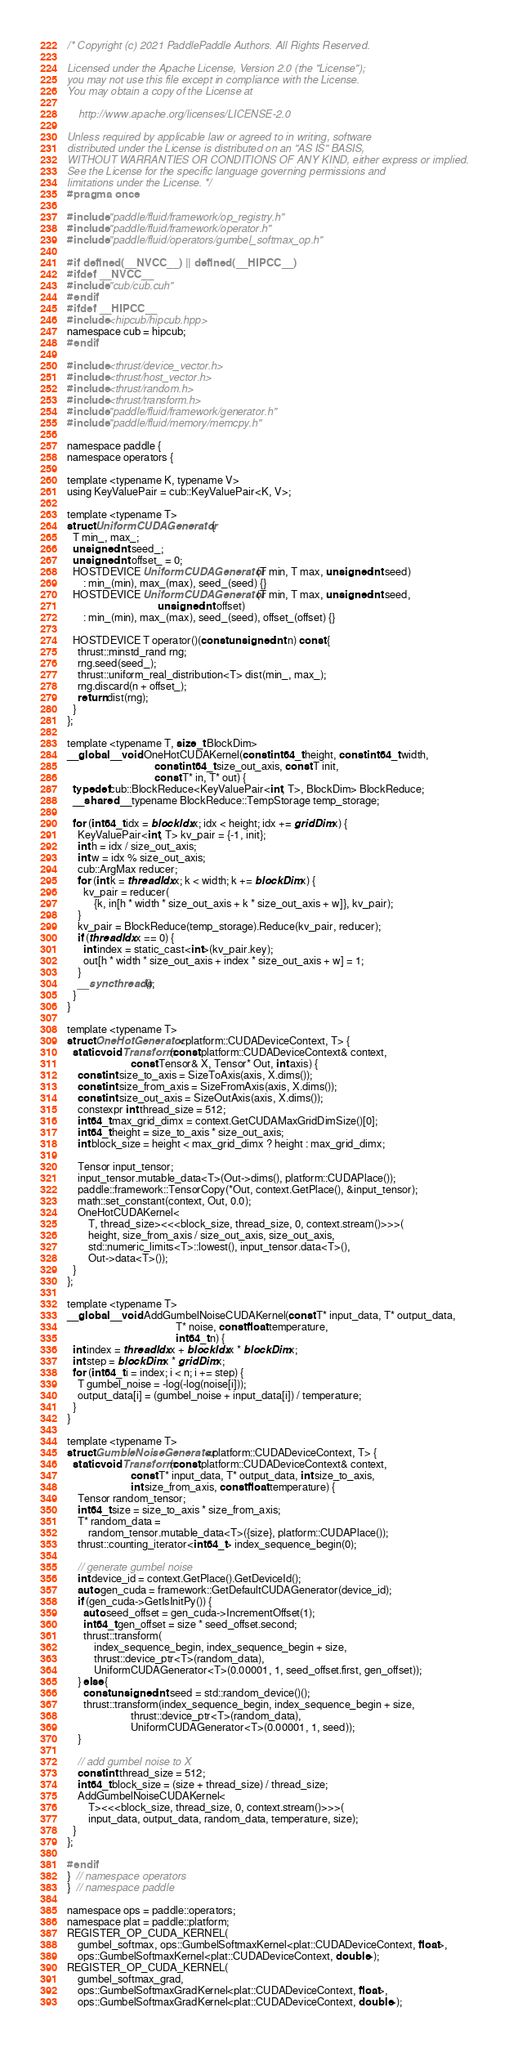Convert code to text. <code><loc_0><loc_0><loc_500><loc_500><_Cuda_>/* Copyright (c) 2021 PaddlePaddle Authors. All Rights Reserved.

Licensed under the Apache License, Version 2.0 (the "License");
you may not use this file except in compliance with the License.
You may obtain a copy of the License at

    http://www.apache.org/licenses/LICENSE-2.0

Unless required by applicable law or agreed to in writing, software
distributed under the License is distributed on an "AS IS" BASIS,
WITHOUT WARRANTIES OR CONDITIONS OF ANY KIND, either express or implied.
See the License for the specific language governing permissions and
limitations under the License. */
#pragma once

#include "paddle/fluid/framework/op_registry.h"
#include "paddle/fluid/framework/operator.h"
#include "paddle/fluid/operators/gumbel_softmax_op.h"

#if defined(__NVCC__) || defined(__HIPCC__)
#ifdef __NVCC__
#include "cub/cub.cuh"
#endif
#ifdef __HIPCC__
#include <hipcub/hipcub.hpp>
namespace cub = hipcub;
#endif

#include <thrust/device_vector.h>
#include <thrust/host_vector.h>
#include <thrust/random.h>
#include <thrust/transform.h>
#include "paddle/fluid/framework/generator.h"
#include "paddle/fluid/memory/memcpy.h"

namespace paddle {
namespace operators {

template <typename K, typename V>
using KeyValuePair = cub::KeyValuePair<K, V>;

template <typename T>
struct UniformCUDAGenerator {
  T min_, max_;
  unsigned int seed_;
  unsigned int offset_ = 0;
  HOSTDEVICE UniformCUDAGenerator(T min, T max, unsigned int seed)
      : min_(min), max_(max), seed_(seed) {}
  HOSTDEVICE UniformCUDAGenerator(T min, T max, unsigned int seed,
                                  unsigned int offset)
      : min_(min), max_(max), seed_(seed), offset_(offset) {}

  HOSTDEVICE T operator()(const unsigned int n) const {
    thrust::minstd_rand rng;
    rng.seed(seed_);
    thrust::uniform_real_distribution<T> dist(min_, max_);
    rng.discard(n + offset_);
    return dist(rng);
  }
};

template <typename T, size_t BlockDim>
__global__ void OneHotCUDAKernel(const int64_t height, const int64_t width,
                                 const int64_t size_out_axis, const T init,
                                 const T* in, T* out) {
  typedef cub::BlockReduce<KeyValuePair<int, T>, BlockDim> BlockReduce;
  __shared__ typename BlockReduce::TempStorage temp_storage;

  for (int64_t idx = blockIdx.x; idx < height; idx += gridDim.x) {
    KeyValuePair<int, T> kv_pair = {-1, init};
    int h = idx / size_out_axis;
    int w = idx % size_out_axis;
    cub::ArgMax reducer;
    for (int k = threadIdx.x; k < width; k += blockDim.x) {
      kv_pair = reducer(
          {k, in[h * width * size_out_axis + k * size_out_axis + w]}, kv_pair);
    }
    kv_pair = BlockReduce(temp_storage).Reduce(kv_pair, reducer);
    if (threadIdx.x == 0) {
      int index = static_cast<int>(kv_pair.key);
      out[h * width * size_out_axis + index * size_out_axis + w] = 1;
    }
    __syncthreads();
  }
}

template <typename T>
struct OneHotGenerator<platform::CUDADeviceContext, T> {
  static void Transform(const platform::CUDADeviceContext& context,
                        const Tensor& X, Tensor* Out, int axis) {
    const int size_to_axis = SizeToAxis(axis, X.dims());
    const int size_from_axis = SizeFromAxis(axis, X.dims());
    const int size_out_axis = SizeOutAxis(axis, X.dims());
    constexpr int thread_size = 512;
    int64_t max_grid_dimx = context.GetCUDAMaxGridDimSize()[0];
    int64_t height = size_to_axis * size_out_axis;
    int block_size = height < max_grid_dimx ? height : max_grid_dimx;

    Tensor input_tensor;
    input_tensor.mutable_data<T>(Out->dims(), platform::CUDAPlace());
    paddle::framework::TensorCopy(*Out, context.GetPlace(), &input_tensor);
    math::set_constant(context, Out, 0.0);
    OneHotCUDAKernel<
        T, thread_size><<<block_size, thread_size, 0, context.stream()>>>(
        height, size_from_axis / size_out_axis, size_out_axis,
        std::numeric_limits<T>::lowest(), input_tensor.data<T>(),
        Out->data<T>());
  }
};

template <typename T>
__global__ void AddGumbelNoiseCUDAKernel(const T* input_data, T* output_data,
                                         T* noise, const float temperature,
                                         int64_t n) {
  int index = threadIdx.x + blockIdx.x * blockDim.x;
  int step = blockDim.x * gridDim.x;
  for (int64_t i = index; i < n; i += step) {
    T gumbel_noise = -log(-log(noise[i]));
    output_data[i] = (gumbel_noise + input_data[i]) / temperature;
  }
}

template <typename T>
struct GumbleNoiseGenerator<platform::CUDADeviceContext, T> {
  static void Transform(const platform::CUDADeviceContext& context,
                        const T* input_data, T* output_data, int size_to_axis,
                        int size_from_axis, const float temperature) {
    Tensor random_tensor;
    int64_t size = size_to_axis * size_from_axis;
    T* random_data =
        random_tensor.mutable_data<T>({size}, platform::CUDAPlace());
    thrust::counting_iterator<int64_t> index_sequence_begin(0);

    // generate gumbel noise
    int device_id = context.GetPlace().GetDeviceId();
    auto gen_cuda = framework::GetDefaultCUDAGenerator(device_id);
    if (gen_cuda->GetIsInitPy()) {
      auto seed_offset = gen_cuda->IncrementOffset(1);
      int64_t gen_offset = size * seed_offset.second;
      thrust::transform(
          index_sequence_begin, index_sequence_begin + size,
          thrust::device_ptr<T>(random_data),
          UniformCUDAGenerator<T>(0.00001, 1, seed_offset.first, gen_offset));
    } else {
      const unsigned int seed = std::random_device()();
      thrust::transform(index_sequence_begin, index_sequence_begin + size,
                        thrust::device_ptr<T>(random_data),
                        UniformCUDAGenerator<T>(0.00001, 1, seed));
    }

    // add gumbel noise to X
    const int thread_size = 512;
    int64_t block_size = (size + thread_size) / thread_size;
    AddGumbelNoiseCUDAKernel<
        T><<<block_size, thread_size, 0, context.stream()>>>(
        input_data, output_data, random_data, temperature, size);
  }
};

#endif
}  // namespace operators
}  // namespace paddle

namespace ops = paddle::operators;
namespace plat = paddle::platform;
REGISTER_OP_CUDA_KERNEL(
    gumbel_softmax, ops::GumbelSoftmaxKernel<plat::CUDADeviceContext, float>,
    ops::GumbelSoftmaxKernel<plat::CUDADeviceContext, double>);
REGISTER_OP_CUDA_KERNEL(
    gumbel_softmax_grad,
    ops::GumbelSoftmaxGradKernel<plat::CUDADeviceContext, float>,
    ops::GumbelSoftmaxGradKernel<plat::CUDADeviceContext, double>);
</code> 